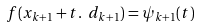<formula> <loc_0><loc_0><loc_500><loc_500>f ( x _ { k + 1 } + t . \ d _ { k + 1 } ) = \psi _ { k + 1 } ( t )</formula> 